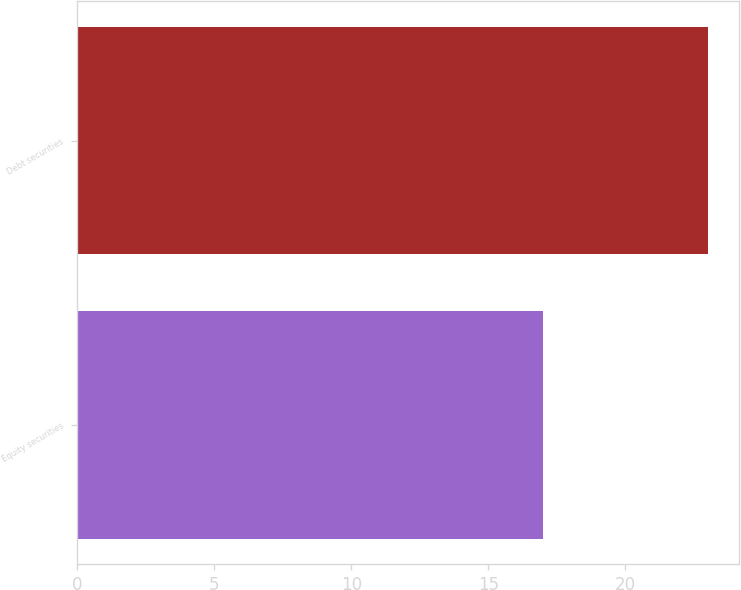<chart> <loc_0><loc_0><loc_500><loc_500><bar_chart><fcel>Equity securities<fcel>Debt securities<nl><fcel>17<fcel>23<nl></chart> 